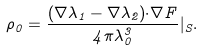Convert formula to latex. <formula><loc_0><loc_0><loc_500><loc_500>\rho _ { 0 } = \frac { ( { \nabla } \lambda _ { 1 } - { \nabla } \lambda _ { 2 } ) { \cdot } { \nabla } F } { 4 { \pi } \lambda _ { 0 } ^ { 3 } } | _ { S } .</formula> 